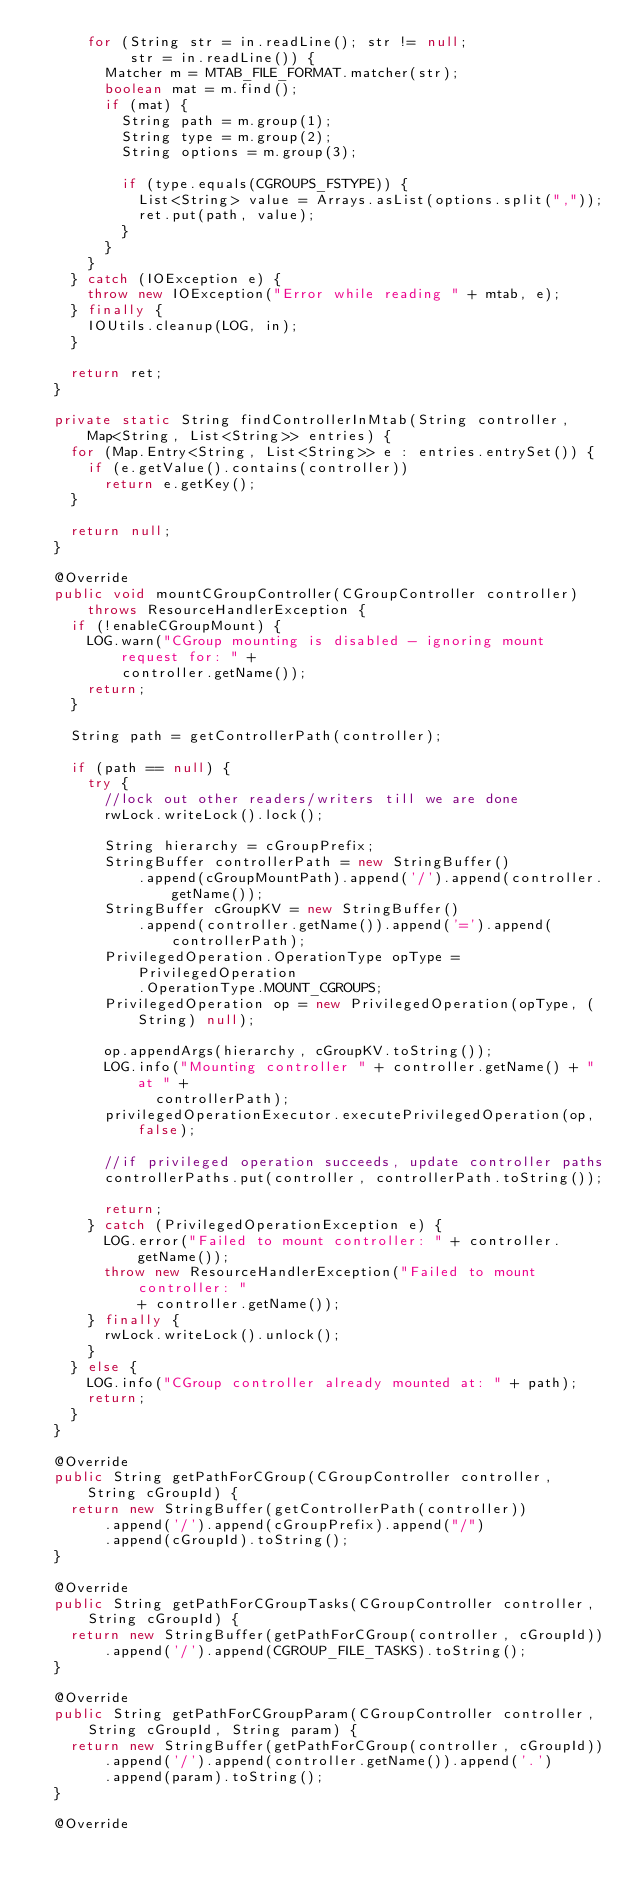<code> <loc_0><loc_0><loc_500><loc_500><_Java_>      for (String str = in.readLine(); str != null;
           str = in.readLine()) {
        Matcher m = MTAB_FILE_FORMAT.matcher(str);
        boolean mat = m.find();
        if (mat) {
          String path = m.group(1);
          String type = m.group(2);
          String options = m.group(3);

          if (type.equals(CGROUPS_FSTYPE)) {
            List<String> value = Arrays.asList(options.split(","));
            ret.put(path, value);
          }
        }
      }
    } catch (IOException e) {
      throw new IOException("Error while reading " + mtab, e);
    } finally {
      IOUtils.cleanup(LOG, in);
    }

    return ret;
  }

  private static String findControllerInMtab(String controller,
      Map<String, List<String>> entries) {
    for (Map.Entry<String, List<String>> e : entries.entrySet()) {
      if (e.getValue().contains(controller))
        return e.getKey();
    }

    return null;
  }

  @Override
  public void mountCGroupController(CGroupController controller)
      throws ResourceHandlerException {
    if (!enableCGroupMount) {
      LOG.warn("CGroup mounting is disabled - ignoring mount request for: " +
          controller.getName());
      return;
    }

    String path = getControllerPath(controller);

    if (path == null) {
      try {
        //lock out other readers/writers till we are done
        rwLock.writeLock().lock();

        String hierarchy = cGroupPrefix;
        StringBuffer controllerPath = new StringBuffer()
            .append(cGroupMountPath).append('/').append(controller.getName());
        StringBuffer cGroupKV = new StringBuffer()
            .append(controller.getName()).append('=').append(controllerPath);
        PrivilegedOperation.OperationType opType = PrivilegedOperation
            .OperationType.MOUNT_CGROUPS;
        PrivilegedOperation op = new PrivilegedOperation(opType, (String) null);

        op.appendArgs(hierarchy, cGroupKV.toString());
        LOG.info("Mounting controller " + controller.getName() + " at " +
              controllerPath);
        privilegedOperationExecutor.executePrivilegedOperation(op, false);

        //if privileged operation succeeds, update controller paths
        controllerPaths.put(controller, controllerPath.toString());

        return;
      } catch (PrivilegedOperationException e) {
        LOG.error("Failed to mount controller: " + controller.getName());
        throw new ResourceHandlerException("Failed to mount controller: "
            + controller.getName());
      } finally {
        rwLock.writeLock().unlock();
      }
    } else {
      LOG.info("CGroup controller already mounted at: " + path);
      return;
    }
  }

  @Override
  public String getPathForCGroup(CGroupController controller, String cGroupId) {
    return new StringBuffer(getControllerPath(controller))
        .append('/').append(cGroupPrefix).append("/")
        .append(cGroupId).toString();
  }

  @Override
  public String getPathForCGroupTasks(CGroupController controller,
      String cGroupId) {
    return new StringBuffer(getPathForCGroup(controller, cGroupId))
        .append('/').append(CGROUP_FILE_TASKS).toString();
  }

  @Override
  public String getPathForCGroupParam(CGroupController controller,
      String cGroupId, String param) {
    return new StringBuffer(getPathForCGroup(controller, cGroupId))
        .append('/').append(controller.getName()).append('.')
        .append(param).toString();
  }

  @Override</code> 